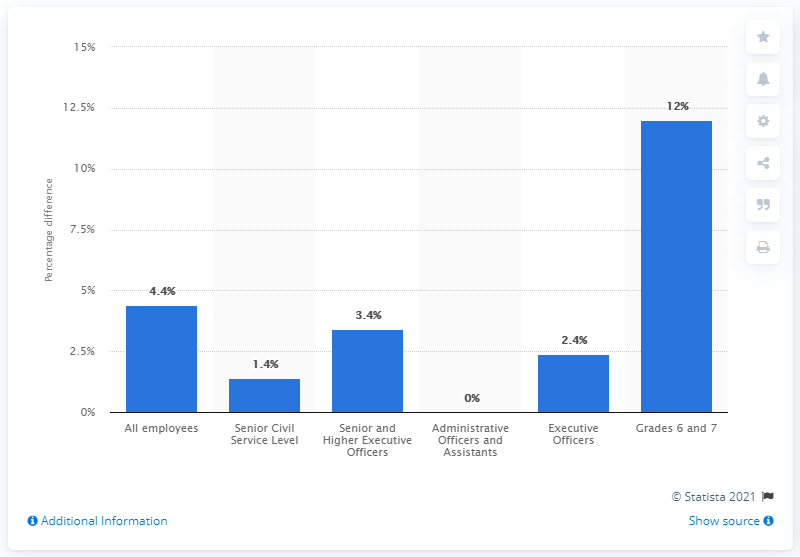Specify some key components in this picture. As of August 26, 2020, the gender pay gap in the civil service of the UK was 12%. 